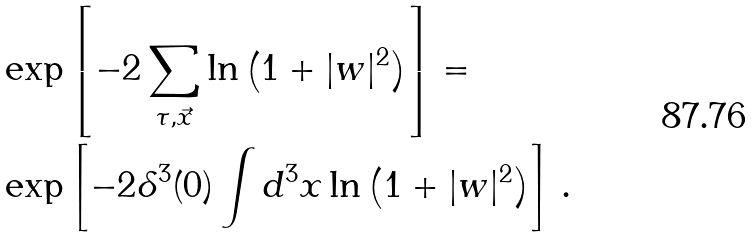<formula> <loc_0><loc_0><loc_500><loc_500>& \exp \left [ - 2 \sum _ { \tau , \vec { x } } \ln \left ( 1 + | w | ^ { 2 } \right ) \right ] = \\ & \exp \left [ - 2 \delta ^ { 3 } ( 0 ) \int d ^ { 3 } x \ln \left ( 1 + | w | ^ { 2 } \right ) \right ] \, .</formula> 